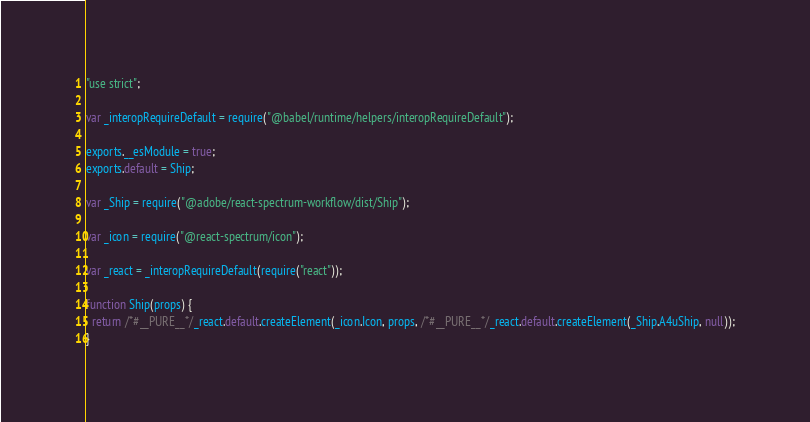Convert code to text. <code><loc_0><loc_0><loc_500><loc_500><_JavaScript_>"use strict";

var _interopRequireDefault = require("@babel/runtime/helpers/interopRequireDefault");

exports.__esModule = true;
exports.default = Ship;

var _Ship = require("@adobe/react-spectrum-workflow/dist/Ship");

var _icon = require("@react-spectrum/icon");

var _react = _interopRequireDefault(require("react"));

function Ship(props) {
  return /*#__PURE__*/_react.default.createElement(_icon.Icon, props, /*#__PURE__*/_react.default.createElement(_Ship.A4uShip, null));
}</code> 